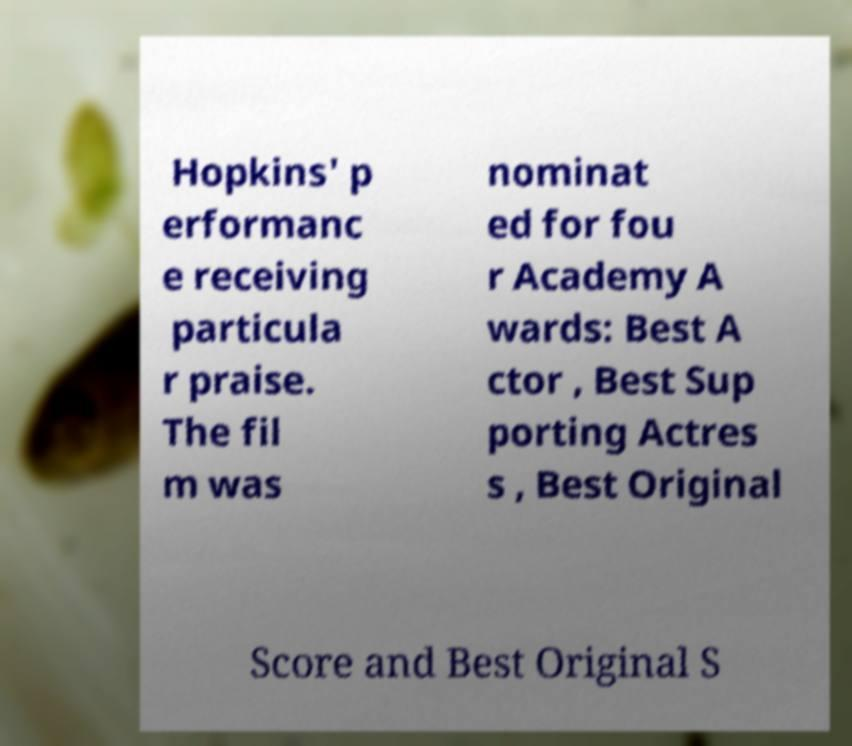There's text embedded in this image that I need extracted. Can you transcribe it verbatim? Hopkins' p erformanc e receiving particula r praise. The fil m was nominat ed for fou r Academy A wards: Best A ctor , Best Sup porting Actres s , Best Original Score and Best Original S 